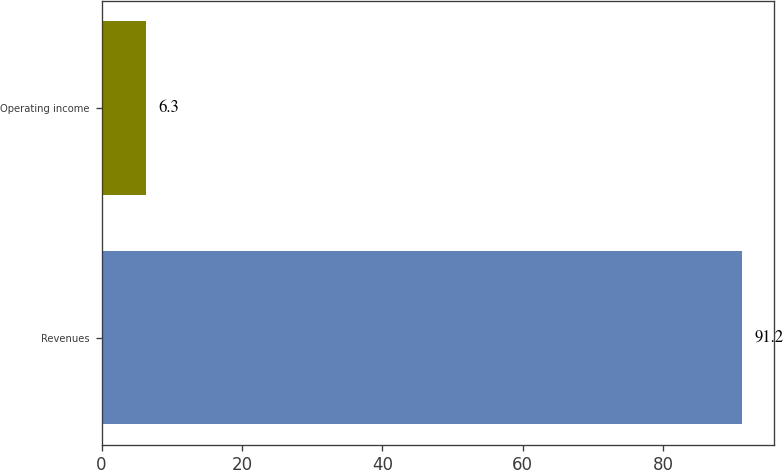Convert chart to OTSL. <chart><loc_0><loc_0><loc_500><loc_500><bar_chart><fcel>Revenues<fcel>Operating income<nl><fcel>91.2<fcel>6.3<nl></chart> 